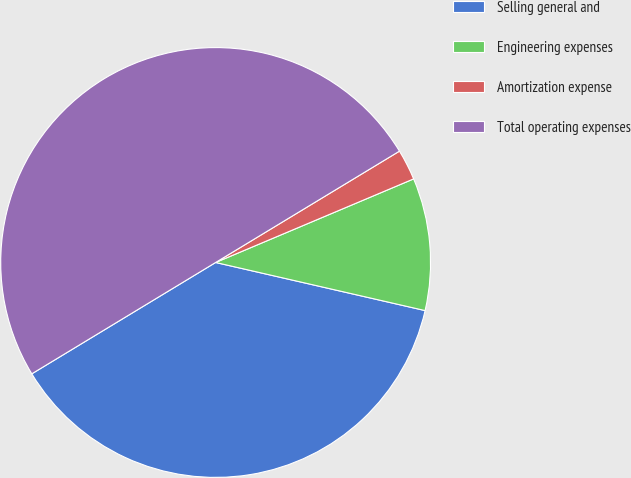Convert chart to OTSL. <chart><loc_0><loc_0><loc_500><loc_500><pie_chart><fcel>Selling general and<fcel>Engineering expenses<fcel>Amortization expense<fcel>Total operating expenses<nl><fcel>37.74%<fcel>9.95%<fcel>2.31%<fcel>50.0%<nl></chart> 